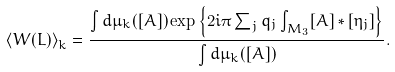<formula> <loc_0><loc_0><loc_500><loc_500>\left \langle W ( L ) \right \rangle _ { k } = \frac { \int d \mu _ { k } ( [ A ] ) \exp \left \{ { 2 i \pi \sum _ { j } q _ { j } \int _ { M _ { 3 } } [ A ] * [ \eta _ { j } ] } \right \} } { \int d \mu _ { k } ( [ A ] ) } .</formula> 